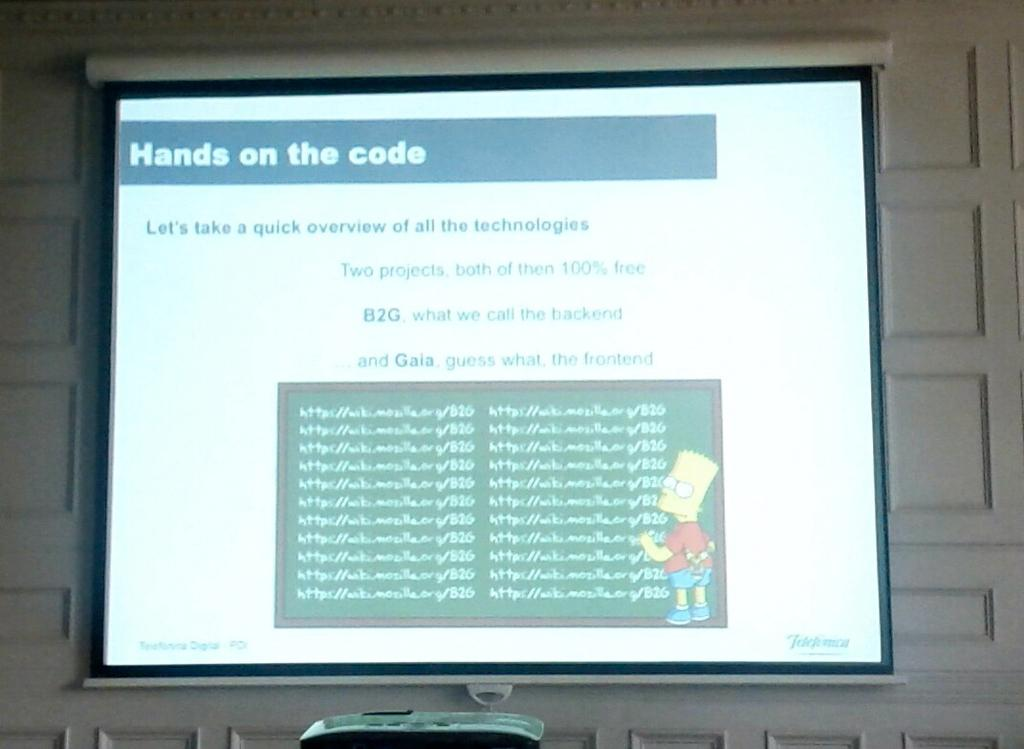<image>
Share a concise interpretation of the image provided. A screen sitting on a wall displays a picture of Bart Simpson the words "hands on the code" 